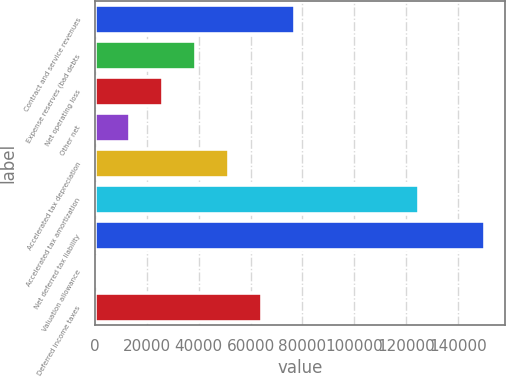<chart> <loc_0><loc_0><loc_500><loc_500><bar_chart><fcel>Contract and service revenues<fcel>Expense reserves (bad debts<fcel>Net operating loss<fcel>Other net<fcel>Accelerated tax depreciation<fcel>Accelerated tax amortization<fcel>Net deferred tax liability<fcel>Valuation allowance<fcel>Deferred income taxes<nl><fcel>76968.4<fcel>38834.2<fcel>26122.8<fcel>13411.4<fcel>51545.6<fcel>125054<fcel>150477<fcel>700<fcel>64257<nl></chart> 